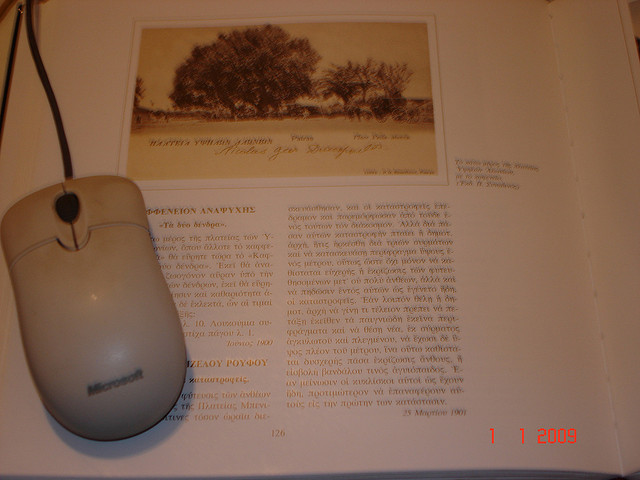How does the presence of the computer mouse modify your perception of the traditional book reading experience depicted in this image? The inclusion of the computer mouse alongside the traditional book page in this image intriguingly suggests a shift in reading habits from purely physical to interactive, digital forms. It poses questions about the integration of digital tools in literary exploration and how they might enhance or detract from the experience of absorbing textual narratives. 